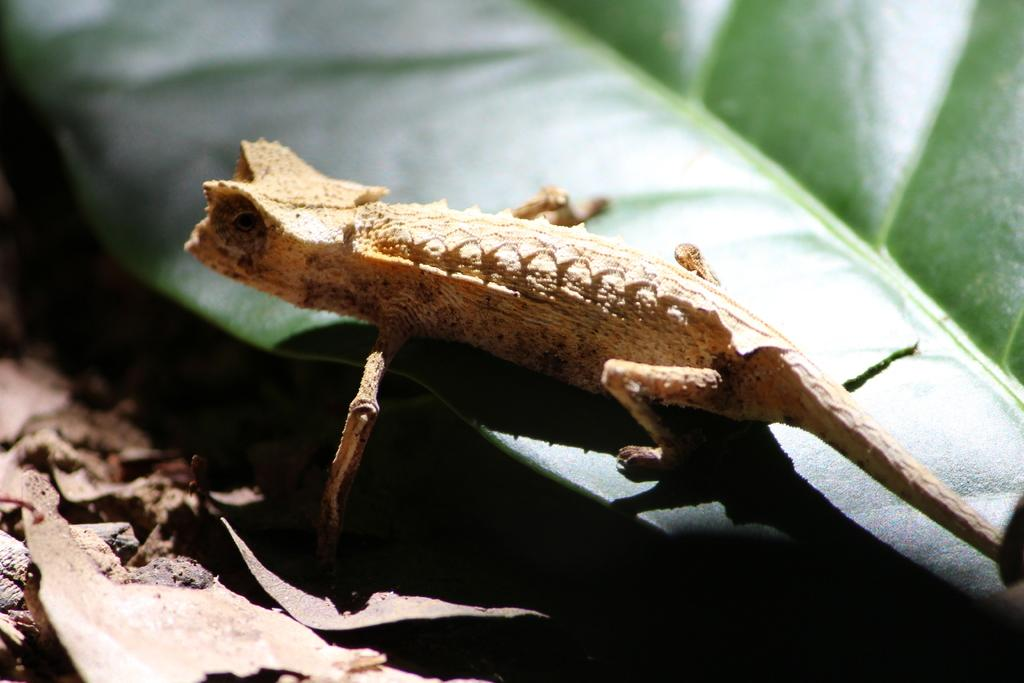What type of animal is in the image? There is a lizard in the image. Where is the lizard located? The lizard is on a leaf. What type of finger can be seen holding the lizard in the image? There is no finger holding the lizard in the image; the lizard is on a leaf. How many birds are visible in the image? There are no birds present in the image. 